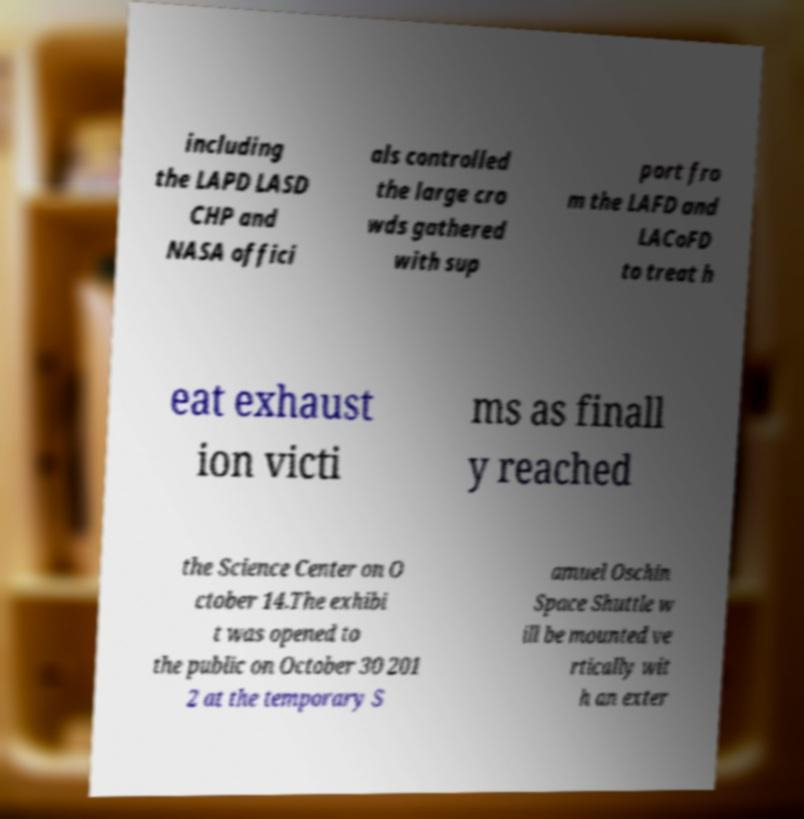What messages or text are displayed in this image? I need them in a readable, typed format. including the LAPD LASD CHP and NASA offici als controlled the large cro wds gathered with sup port fro m the LAFD and LACoFD to treat h eat exhaust ion victi ms as finall y reached the Science Center on O ctober 14.The exhibi t was opened to the public on October 30 201 2 at the temporary S amuel Oschin Space Shuttle w ill be mounted ve rtically wit h an exter 